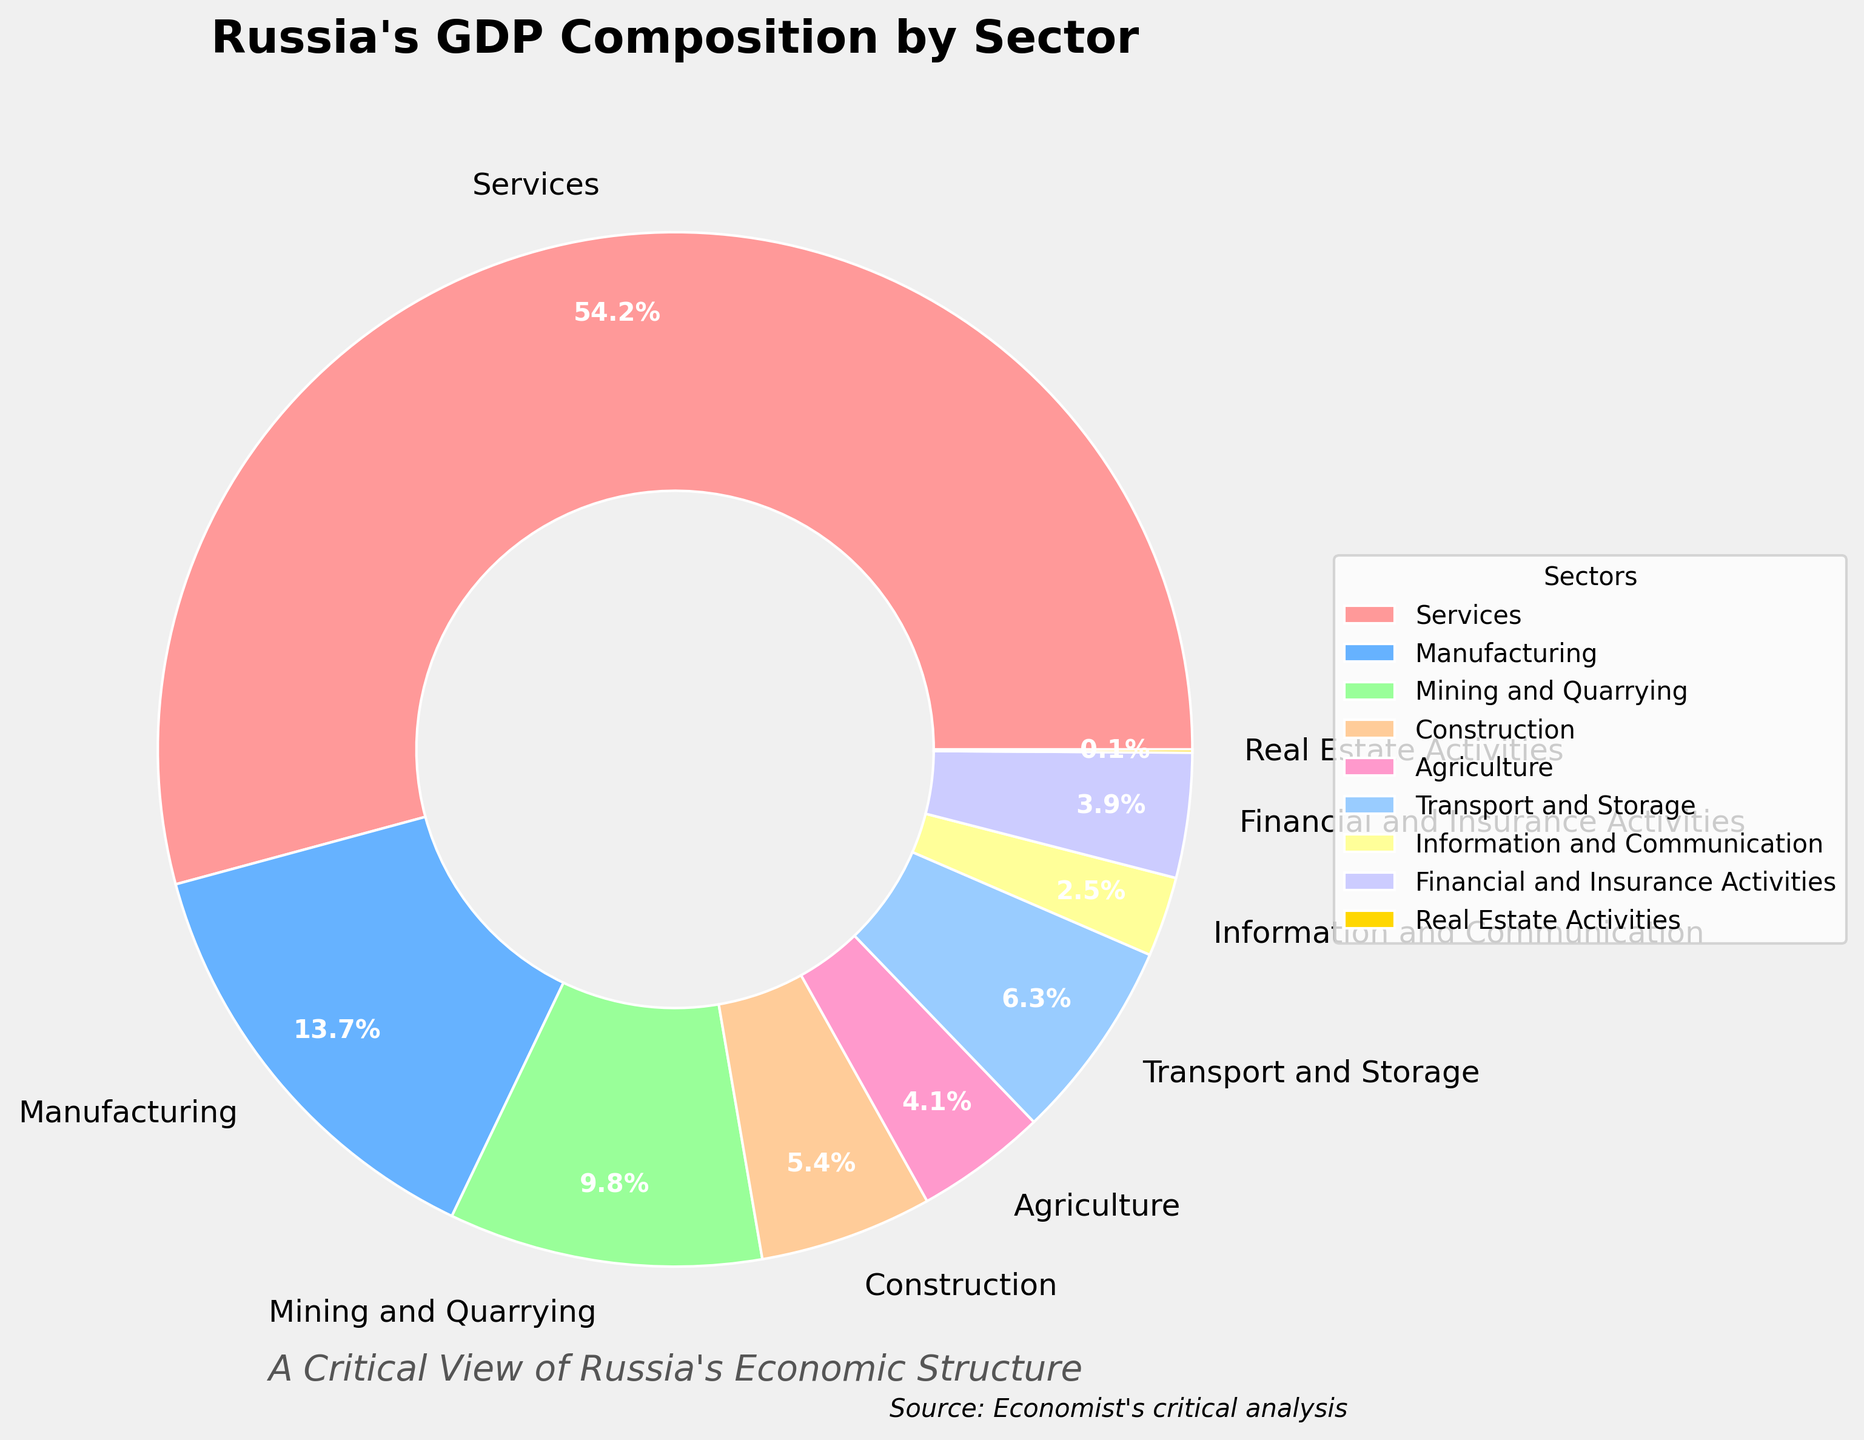What sector has the largest share of Russia's GDP? The figure shows the GDP composition by sector in a pie chart. The largest share is labeled 'Services' with 54.2%.
Answer: Services Which sector has a smaller share, Agriculture or Financial and Insurance Activities? The pie chart indicates Agriculture at 4.1% and Financial and Insurance Activities at 3.9%. Since 3.9% is smaller than 4.1%, Financial and Insurance Activities have the smaller share.
Answer: Financial and Insurance Activities What is the combined percentage of Manufacturing, Mining and Quarrying, and Construction? The figure provides separate percentages for Manufacturing (13.7%), Mining and Quarrying (9.8%), and Construction (5.4%). Adding them together gives 13.7% + 9.8% + 5.4% = 28.9%.
Answer: 28.9% How does the share of Transport and Storage compare to that of Agriculture? The figure shows Transport and Storage at 6.3% and Agriculture at 4.1%. Since 6.3% is greater than 4.1%, the share of Transport and Storage is larger than that of Agriculture.
Answer: Transport and Storage What is the difference in GDP share between the largest and smallest sectors? The largest sector is Services at 54.2%, and the smallest is Real Estate Activities at 0.1%. The difference is 54.2% - 0.1% = 54.1%.
Answer: 54.1% Are Information and Communication activities above or below 5% of Russia's GDP? The pie chart shows Information and Communication at 2.5%, which is below 5%.
Answer: Below 5% What is the total GDP percentage accounted for by sectors other than Services? Subtracting the Services sector (54.2%) from 100% results in 100% - 54.2% = 45.8%.
Answer: 45.8% Which sector has the smallest share of Russia's GDP, and what is its percentage? The sector with the smallest share is Real Estate Activities, which is 0.1%, as indicated in the pie chart.
Answer: Real Estate Activities, 0.1% What is the mean percentage share of GDP for Mining and Quarrying, Construction, and Agriculture? The percentage shares are 9.8% for Mining and Quarrying, 5.4% for Construction, and 4.1% for Agriculture. The mean is calculated as (9.8 + 5.4 + 4.1)/3 = 6.4333%, rounded to 6.4%.
Answer: 6.4% 